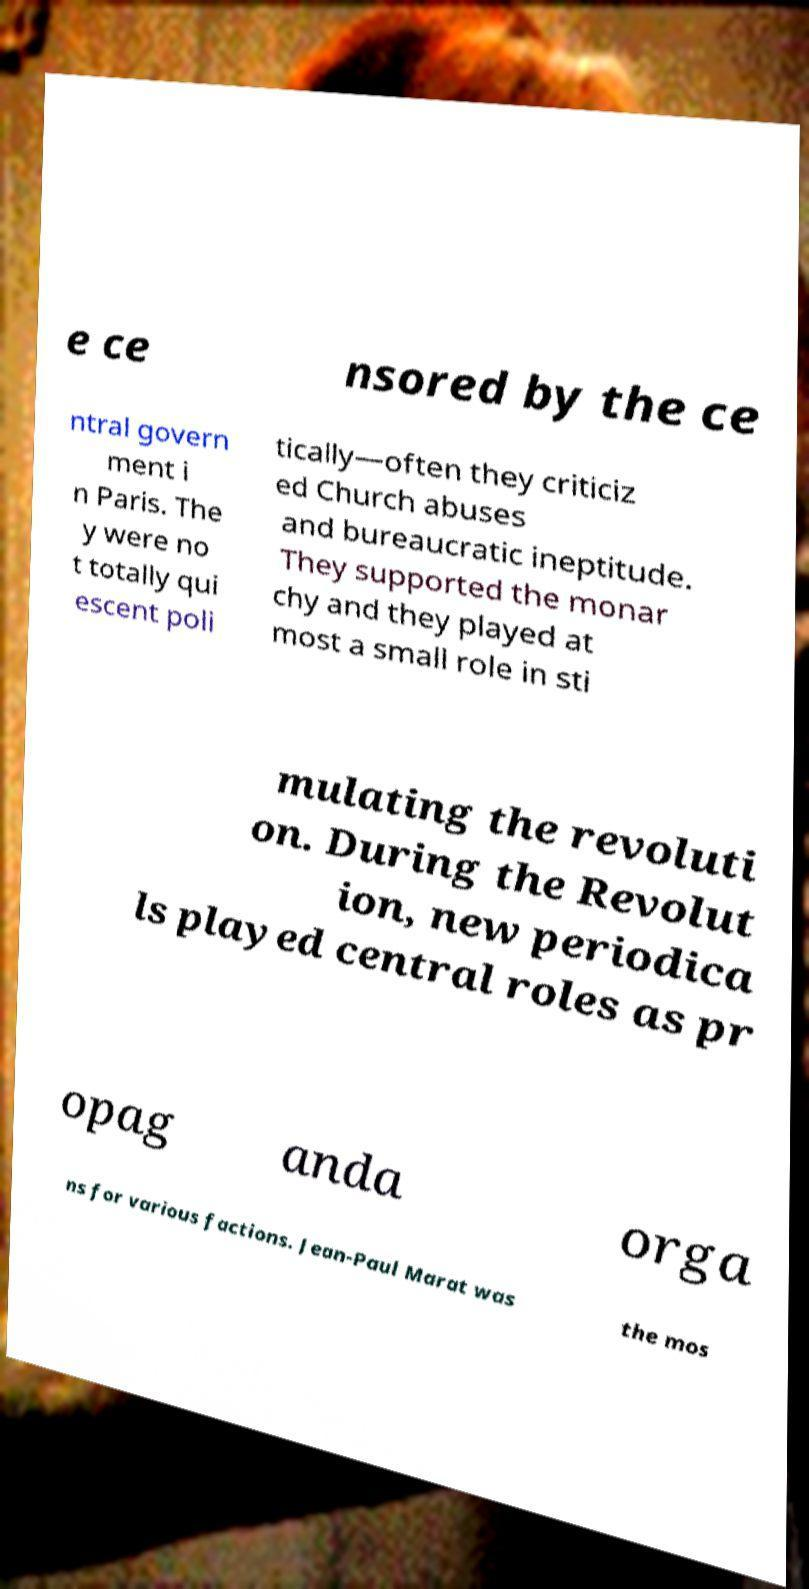There's text embedded in this image that I need extracted. Can you transcribe it verbatim? e ce nsored by the ce ntral govern ment i n Paris. The y were no t totally qui escent poli tically—often they criticiz ed Church abuses and bureaucratic ineptitude. They supported the monar chy and they played at most a small role in sti mulating the revoluti on. During the Revolut ion, new periodica ls played central roles as pr opag anda orga ns for various factions. Jean-Paul Marat was the mos 